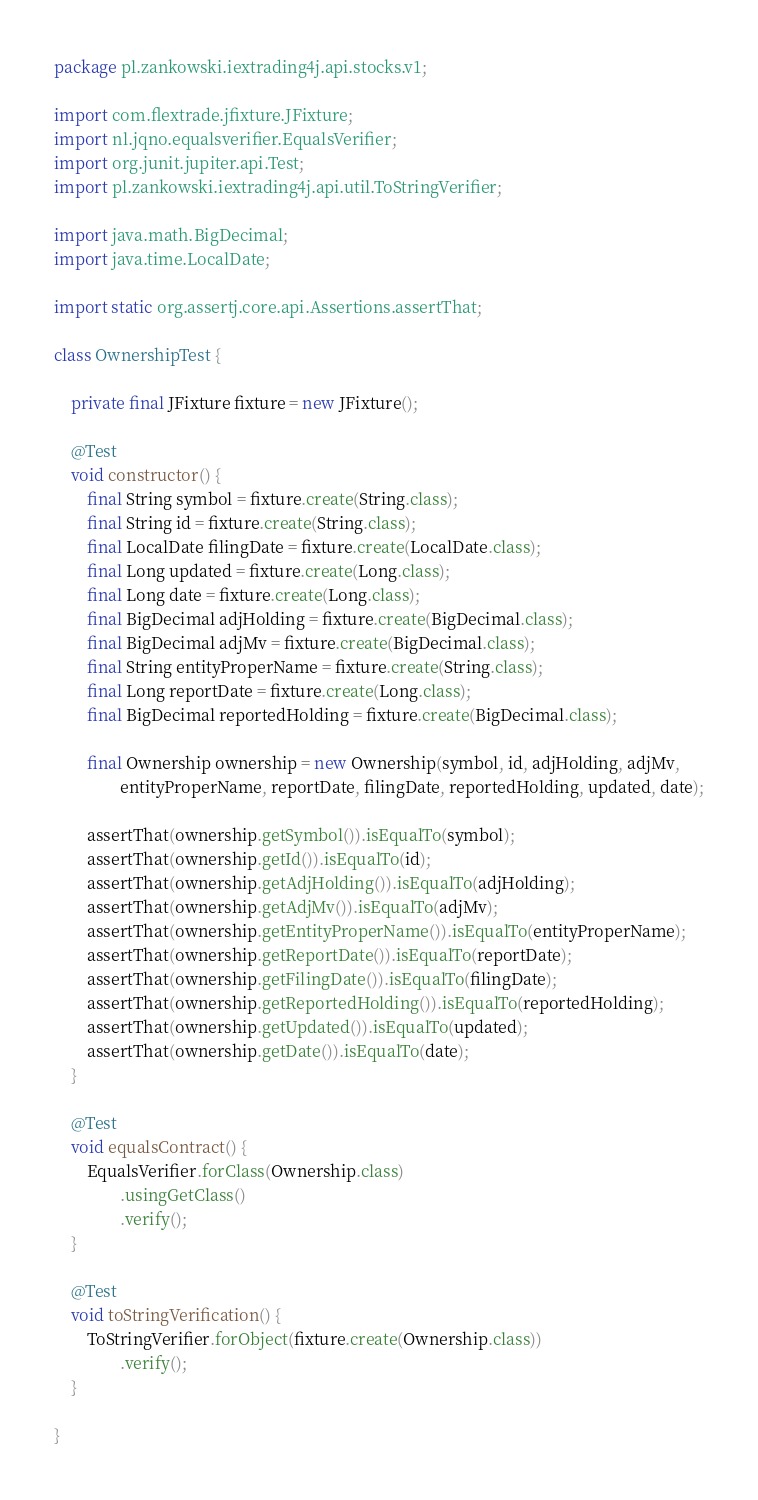Convert code to text. <code><loc_0><loc_0><loc_500><loc_500><_Java_>package pl.zankowski.iextrading4j.api.stocks.v1;

import com.flextrade.jfixture.JFixture;
import nl.jqno.equalsverifier.EqualsVerifier;
import org.junit.jupiter.api.Test;
import pl.zankowski.iextrading4j.api.util.ToStringVerifier;

import java.math.BigDecimal;
import java.time.LocalDate;

import static org.assertj.core.api.Assertions.assertThat;

class OwnershipTest {

    private final JFixture fixture = new JFixture();

    @Test
    void constructor() {
        final String symbol = fixture.create(String.class);
        final String id = fixture.create(String.class);
        final LocalDate filingDate = fixture.create(LocalDate.class);
        final Long updated = fixture.create(Long.class);
        final Long date = fixture.create(Long.class);
        final BigDecimal adjHolding = fixture.create(BigDecimal.class);
        final BigDecimal adjMv = fixture.create(BigDecimal.class);
        final String entityProperName = fixture.create(String.class);
        final Long reportDate = fixture.create(Long.class);
        final BigDecimal reportedHolding = fixture.create(BigDecimal.class);

        final Ownership ownership = new Ownership(symbol, id, adjHolding, adjMv,
                entityProperName, reportDate, filingDate, reportedHolding, updated, date);

        assertThat(ownership.getSymbol()).isEqualTo(symbol);
        assertThat(ownership.getId()).isEqualTo(id);
        assertThat(ownership.getAdjHolding()).isEqualTo(adjHolding);
        assertThat(ownership.getAdjMv()).isEqualTo(adjMv);
        assertThat(ownership.getEntityProperName()).isEqualTo(entityProperName);
        assertThat(ownership.getReportDate()).isEqualTo(reportDate);
        assertThat(ownership.getFilingDate()).isEqualTo(filingDate);
        assertThat(ownership.getReportedHolding()).isEqualTo(reportedHolding);
        assertThat(ownership.getUpdated()).isEqualTo(updated);
        assertThat(ownership.getDate()).isEqualTo(date);
    }

    @Test
    void equalsContract() {
        EqualsVerifier.forClass(Ownership.class)
                .usingGetClass()
                .verify();
    }

    @Test
    void toStringVerification() {
        ToStringVerifier.forObject(fixture.create(Ownership.class))
                .verify();
    }

}
</code> 